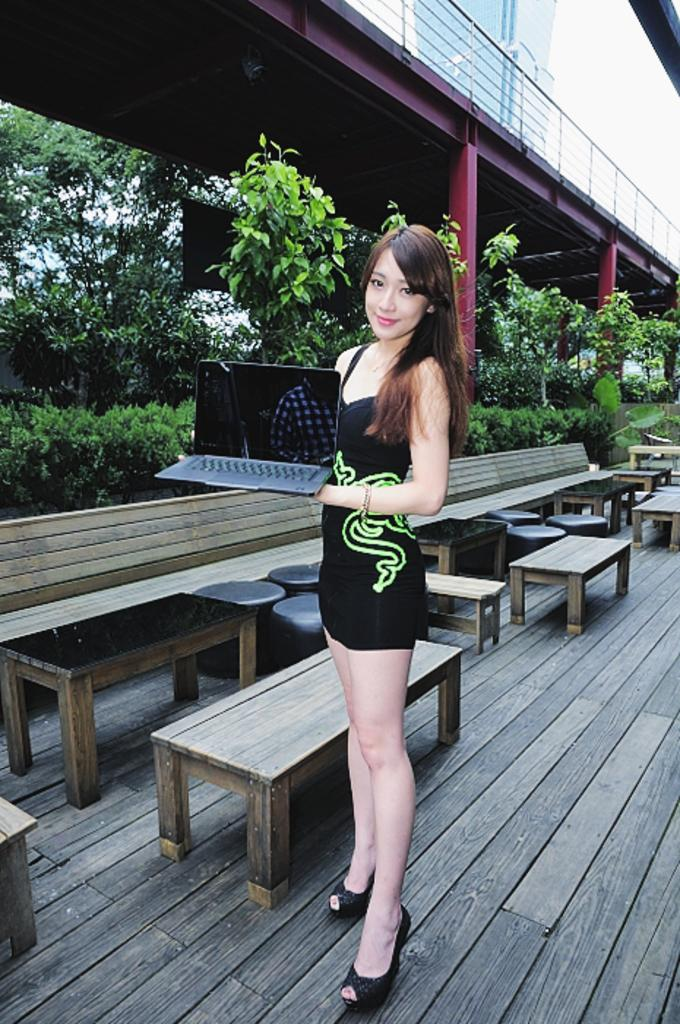What is the lady holding in the image? The lady is holding a laptop in the image. What type of furniture can be seen in the image? There are tables, benches, and stools in the image. What can be seen in the background of the image? There are bushes and trees in the background of the image. Can you describe the architectural feature in the image? There is a bridge with pillars in the image. What type of spoon is being used to construct the bridge in the image? There is no spoon present in the image, and the bridge is already constructed. 